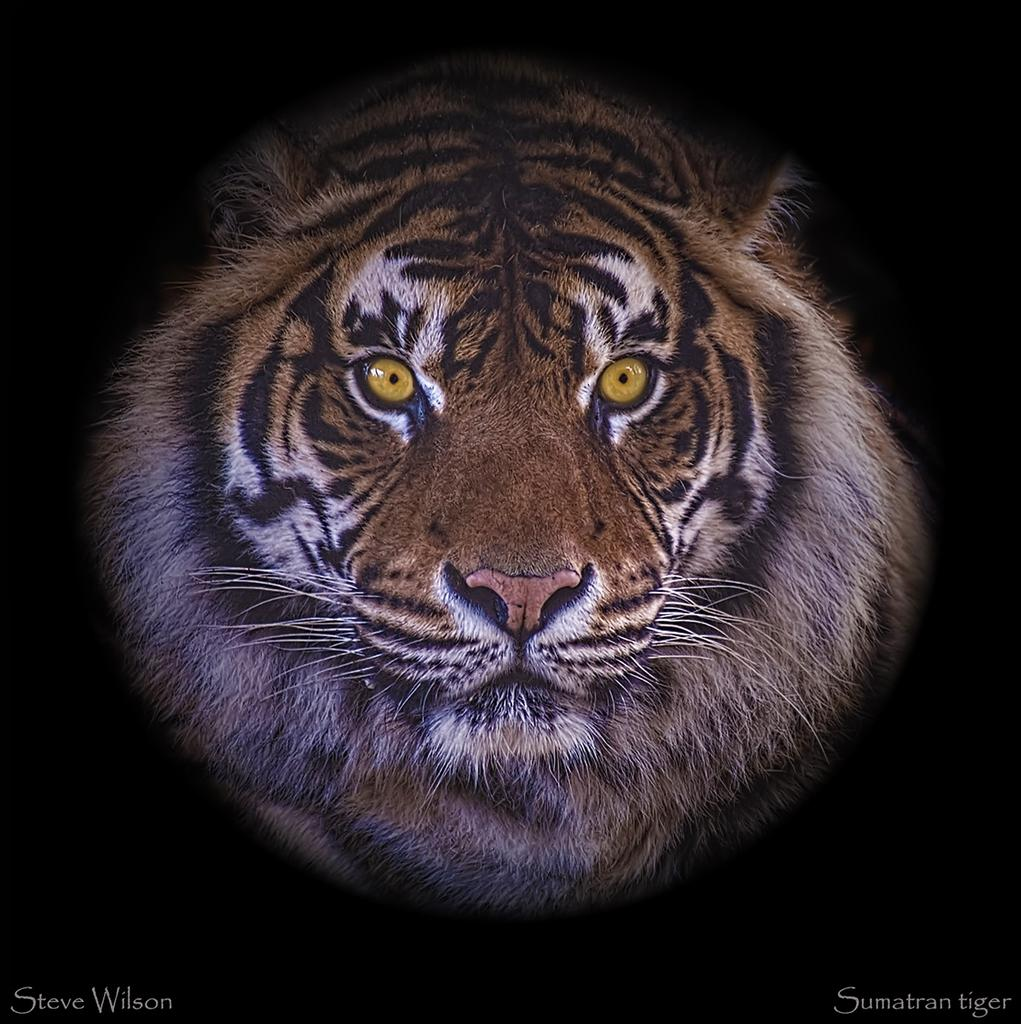What is the main subject of the image? There is a tiger's face in the image. Can you describe the background of the image? The background of the image is dark. Are there any additional features in the image? Yes, there are watermarks in the bottom left and right corners of the image. What type of creature is the queen riding in the image? There is no queen or creature present in the image; it only features a tiger's face and watermarks. 